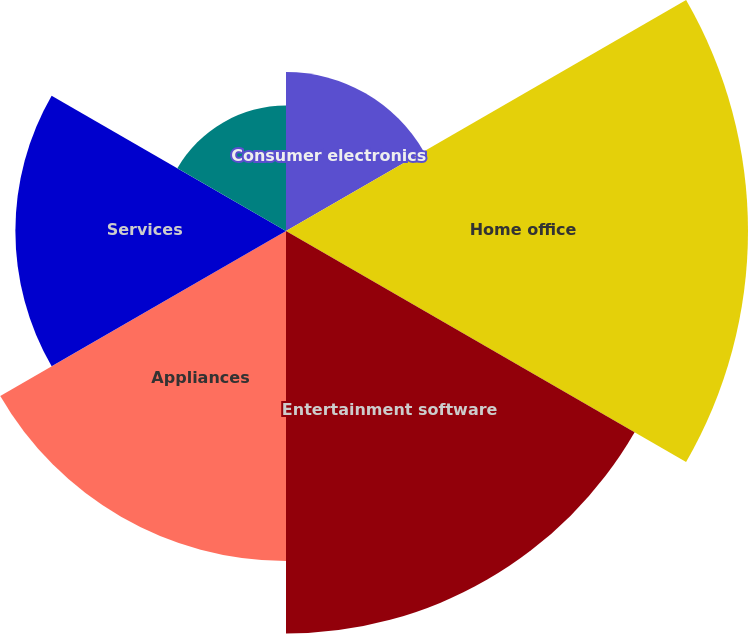Convert chart to OTSL. <chart><loc_0><loc_0><loc_500><loc_500><pie_chart><fcel>Consumer electronics<fcel>Home office<fcel>Entertainment software<fcel>Appliances<fcel>Services<fcel>Total<nl><fcel>9.09%<fcel>26.41%<fcel>23.01%<fcel>18.86%<fcel>15.47%<fcel>7.17%<nl></chart> 